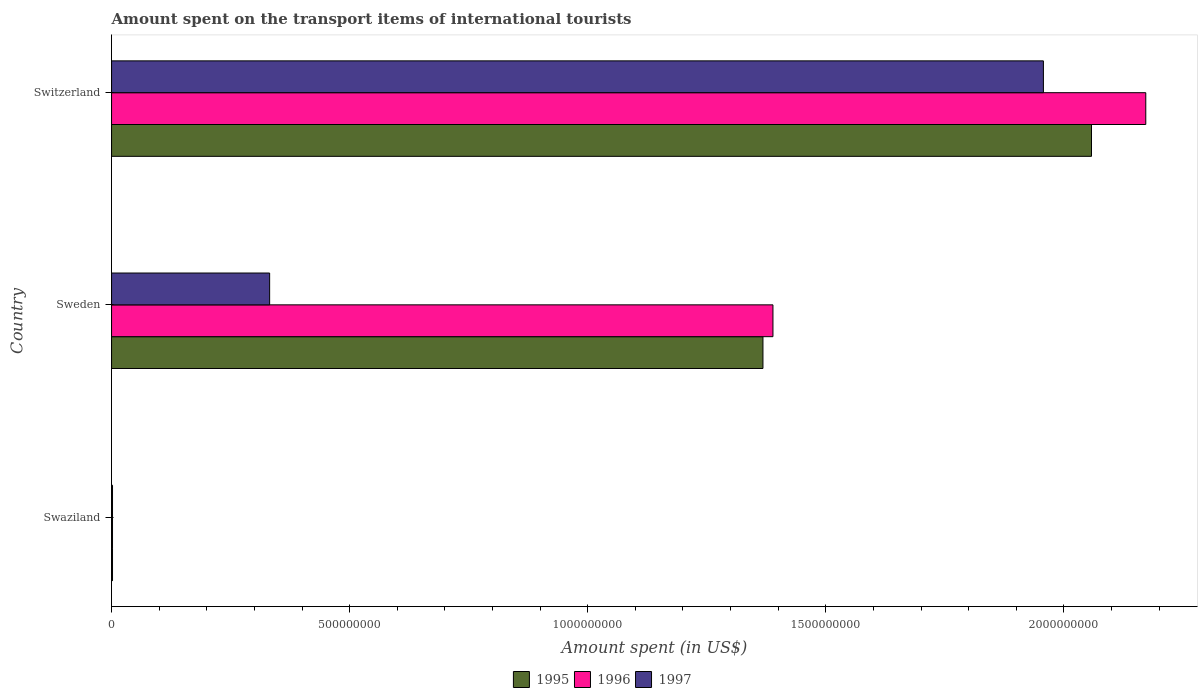How many different coloured bars are there?
Offer a very short reply. 3. Are the number of bars on each tick of the Y-axis equal?
Your answer should be very brief. Yes. How many bars are there on the 1st tick from the bottom?
Provide a succinct answer. 3. What is the amount spent on the transport items of international tourists in 1995 in Sweden?
Offer a very short reply. 1.37e+09. Across all countries, what is the maximum amount spent on the transport items of international tourists in 1995?
Your response must be concise. 2.06e+09. In which country was the amount spent on the transport items of international tourists in 1996 maximum?
Your answer should be compact. Switzerland. In which country was the amount spent on the transport items of international tourists in 1997 minimum?
Make the answer very short. Swaziland. What is the total amount spent on the transport items of international tourists in 1995 in the graph?
Provide a short and direct response. 3.43e+09. What is the difference between the amount spent on the transport items of international tourists in 1995 in Sweden and that in Switzerland?
Your answer should be compact. -6.90e+08. What is the difference between the amount spent on the transport items of international tourists in 1997 in Swaziland and the amount spent on the transport items of international tourists in 1995 in Sweden?
Provide a succinct answer. -1.37e+09. What is the average amount spent on the transport items of international tourists in 1996 per country?
Offer a very short reply. 1.19e+09. What is the difference between the amount spent on the transport items of international tourists in 1997 and amount spent on the transport items of international tourists in 1995 in Swaziland?
Provide a succinct answer. 0. In how many countries, is the amount spent on the transport items of international tourists in 1997 greater than 1400000000 US$?
Offer a very short reply. 1. What is the ratio of the amount spent on the transport items of international tourists in 1996 in Swaziland to that in Sweden?
Offer a terse response. 0. Is the difference between the amount spent on the transport items of international tourists in 1997 in Swaziland and Switzerland greater than the difference between the amount spent on the transport items of international tourists in 1995 in Swaziland and Switzerland?
Offer a terse response. Yes. What is the difference between the highest and the second highest amount spent on the transport items of international tourists in 1996?
Ensure brevity in your answer.  7.83e+08. What is the difference between the highest and the lowest amount spent on the transport items of international tourists in 1995?
Keep it short and to the point. 2.06e+09. In how many countries, is the amount spent on the transport items of international tourists in 1996 greater than the average amount spent on the transport items of international tourists in 1996 taken over all countries?
Provide a succinct answer. 2. Is the sum of the amount spent on the transport items of international tourists in 1995 in Swaziland and Switzerland greater than the maximum amount spent on the transport items of international tourists in 1996 across all countries?
Provide a short and direct response. No. Is it the case that in every country, the sum of the amount spent on the transport items of international tourists in 1997 and amount spent on the transport items of international tourists in 1996 is greater than the amount spent on the transport items of international tourists in 1995?
Ensure brevity in your answer.  Yes. How many bars are there?
Ensure brevity in your answer.  9. What is the difference between two consecutive major ticks on the X-axis?
Offer a very short reply. 5.00e+08. Does the graph contain any zero values?
Ensure brevity in your answer.  No. Does the graph contain grids?
Give a very brief answer. No. How many legend labels are there?
Provide a short and direct response. 3. What is the title of the graph?
Provide a succinct answer. Amount spent on the transport items of international tourists. What is the label or title of the X-axis?
Your answer should be compact. Amount spent (in US$). What is the label or title of the Y-axis?
Your response must be concise. Country. What is the Amount spent (in US$) of 1995 in Swaziland?
Give a very brief answer. 2.00e+06. What is the Amount spent (in US$) in 1995 in Sweden?
Ensure brevity in your answer.  1.37e+09. What is the Amount spent (in US$) in 1996 in Sweden?
Offer a very short reply. 1.39e+09. What is the Amount spent (in US$) in 1997 in Sweden?
Keep it short and to the point. 3.32e+08. What is the Amount spent (in US$) of 1995 in Switzerland?
Your answer should be compact. 2.06e+09. What is the Amount spent (in US$) in 1996 in Switzerland?
Provide a short and direct response. 2.17e+09. What is the Amount spent (in US$) of 1997 in Switzerland?
Provide a short and direct response. 1.96e+09. Across all countries, what is the maximum Amount spent (in US$) in 1995?
Provide a succinct answer. 2.06e+09. Across all countries, what is the maximum Amount spent (in US$) of 1996?
Keep it short and to the point. 2.17e+09. Across all countries, what is the maximum Amount spent (in US$) in 1997?
Your answer should be very brief. 1.96e+09. Across all countries, what is the minimum Amount spent (in US$) of 1996?
Your answer should be compact. 2.00e+06. What is the total Amount spent (in US$) in 1995 in the graph?
Provide a short and direct response. 3.43e+09. What is the total Amount spent (in US$) in 1996 in the graph?
Your answer should be very brief. 3.56e+09. What is the total Amount spent (in US$) in 1997 in the graph?
Your answer should be very brief. 2.29e+09. What is the difference between the Amount spent (in US$) in 1995 in Swaziland and that in Sweden?
Provide a succinct answer. -1.37e+09. What is the difference between the Amount spent (in US$) in 1996 in Swaziland and that in Sweden?
Keep it short and to the point. -1.39e+09. What is the difference between the Amount spent (in US$) of 1997 in Swaziland and that in Sweden?
Give a very brief answer. -3.30e+08. What is the difference between the Amount spent (in US$) in 1995 in Swaziland and that in Switzerland?
Provide a short and direct response. -2.06e+09. What is the difference between the Amount spent (in US$) of 1996 in Swaziland and that in Switzerland?
Your answer should be compact. -2.17e+09. What is the difference between the Amount spent (in US$) in 1997 in Swaziland and that in Switzerland?
Your response must be concise. -1.96e+09. What is the difference between the Amount spent (in US$) in 1995 in Sweden and that in Switzerland?
Your response must be concise. -6.90e+08. What is the difference between the Amount spent (in US$) of 1996 in Sweden and that in Switzerland?
Provide a short and direct response. -7.83e+08. What is the difference between the Amount spent (in US$) of 1997 in Sweden and that in Switzerland?
Your response must be concise. -1.62e+09. What is the difference between the Amount spent (in US$) in 1995 in Swaziland and the Amount spent (in US$) in 1996 in Sweden?
Ensure brevity in your answer.  -1.39e+09. What is the difference between the Amount spent (in US$) of 1995 in Swaziland and the Amount spent (in US$) of 1997 in Sweden?
Make the answer very short. -3.30e+08. What is the difference between the Amount spent (in US$) in 1996 in Swaziland and the Amount spent (in US$) in 1997 in Sweden?
Give a very brief answer. -3.30e+08. What is the difference between the Amount spent (in US$) of 1995 in Swaziland and the Amount spent (in US$) of 1996 in Switzerland?
Your response must be concise. -2.17e+09. What is the difference between the Amount spent (in US$) of 1995 in Swaziland and the Amount spent (in US$) of 1997 in Switzerland?
Give a very brief answer. -1.96e+09. What is the difference between the Amount spent (in US$) in 1996 in Swaziland and the Amount spent (in US$) in 1997 in Switzerland?
Keep it short and to the point. -1.96e+09. What is the difference between the Amount spent (in US$) in 1995 in Sweden and the Amount spent (in US$) in 1996 in Switzerland?
Keep it short and to the point. -8.04e+08. What is the difference between the Amount spent (in US$) of 1995 in Sweden and the Amount spent (in US$) of 1997 in Switzerland?
Your answer should be compact. -5.89e+08. What is the difference between the Amount spent (in US$) in 1996 in Sweden and the Amount spent (in US$) in 1997 in Switzerland?
Offer a terse response. -5.68e+08. What is the average Amount spent (in US$) in 1995 per country?
Ensure brevity in your answer.  1.14e+09. What is the average Amount spent (in US$) in 1996 per country?
Offer a terse response. 1.19e+09. What is the average Amount spent (in US$) in 1997 per country?
Provide a short and direct response. 7.64e+08. What is the difference between the Amount spent (in US$) in 1995 and Amount spent (in US$) in 1996 in Swaziland?
Keep it short and to the point. 0. What is the difference between the Amount spent (in US$) in 1995 and Amount spent (in US$) in 1996 in Sweden?
Offer a very short reply. -2.10e+07. What is the difference between the Amount spent (in US$) of 1995 and Amount spent (in US$) of 1997 in Sweden?
Make the answer very short. 1.04e+09. What is the difference between the Amount spent (in US$) in 1996 and Amount spent (in US$) in 1997 in Sweden?
Give a very brief answer. 1.06e+09. What is the difference between the Amount spent (in US$) of 1995 and Amount spent (in US$) of 1996 in Switzerland?
Provide a short and direct response. -1.14e+08. What is the difference between the Amount spent (in US$) of 1995 and Amount spent (in US$) of 1997 in Switzerland?
Offer a very short reply. 1.01e+08. What is the difference between the Amount spent (in US$) of 1996 and Amount spent (in US$) of 1997 in Switzerland?
Ensure brevity in your answer.  2.15e+08. What is the ratio of the Amount spent (in US$) of 1995 in Swaziland to that in Sweden?
Give a very brief answer. 0. What is the ratio of the Amount spent (in US$) of 1996 in Swaziland to that in Sweden?
Your answer should be very brief. 0. What is the ratio of the Amount spent (in US$) in 1997 in Swaziland to that in Sweden?
Provide a short and direct response. 0.01. What is the ratio of the Amount spent (in US$) in 1995 in Swaziland to that in Switzerland?
Ensure brevity in your answer.  0. What is the ratio of the Amount spent (in US$) in 1996 in Swaziland to that in Switzerland?
Provide a short and direct response. 0. What is the ratio of the Amount spent (in US$) in 1995 in Sweden to that in Switzerland?
Offer a very short reply. 0.66. What is the ratio of the Amount spent (in US$) of 1996 in Sweden to that in Switzerland?
Make the answer very short. 0.64. What is the ratio of the Amount spent (in US$) in 1997 in Sweden to that in Switzerland?
Keep it short and to the point. 0.17. What is the difference between the highest and the second highest Amount spent (in US$) in 1995?
Your response must be concise. 6.90e+08. What is the difference between the highest and the second highest Amount spent (in US$) in 1996?
Offer a very short reply. 7.83e+08. What is the difference between the highest and the second highest Amount spent (in US$) in 1997?
Offer a terse response. 1.62e+09. What is the difference between the highest and the lowest Amount spent (in US$) in 1995?
Your answer should be very brief. 2.06e+09. What is the difference between the highest and the lowest Amount spent (in US$) of 1996?
Offer a terse response. 2.17e+09. What is the difference between the highest and the lowest Amount spent (in US$) of 1997?
Make the answer very short. 1.96e+09. 